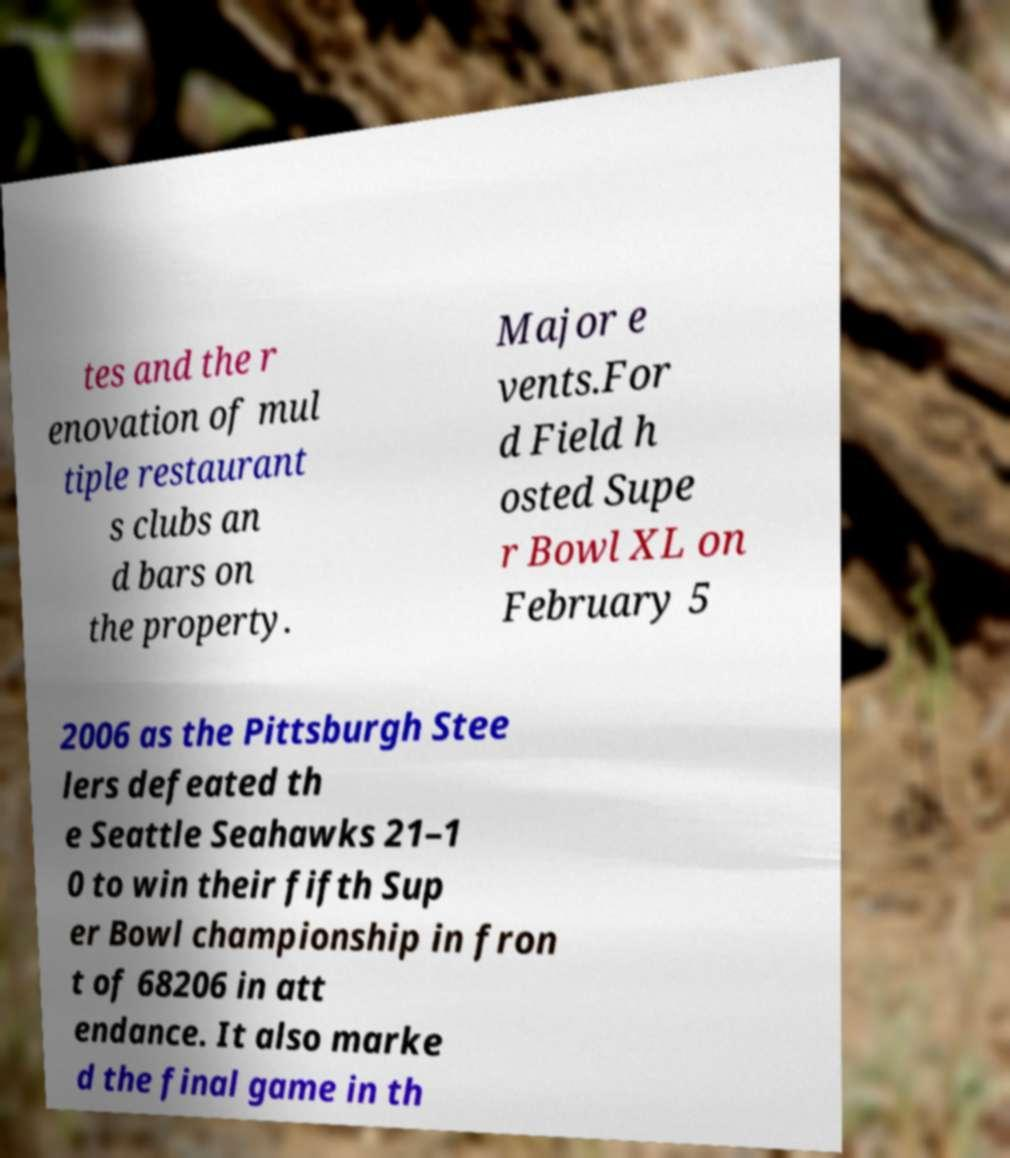There's text embedded in this image that I need extracted. Can you transcribe it verbatim? tes and the r enovation of mul tiple restaurant s clubs an d bars on the property. Major e vents.For d Field h osted Supe r Bowl XL on February 5 2006 as the Pittsburgh Stee lers defeated th e Seattle Seahawks 21–1 0 to win their fifth Sup er Bowl championship in fron t of 68206 in att endance. It also marke d the final game in th 